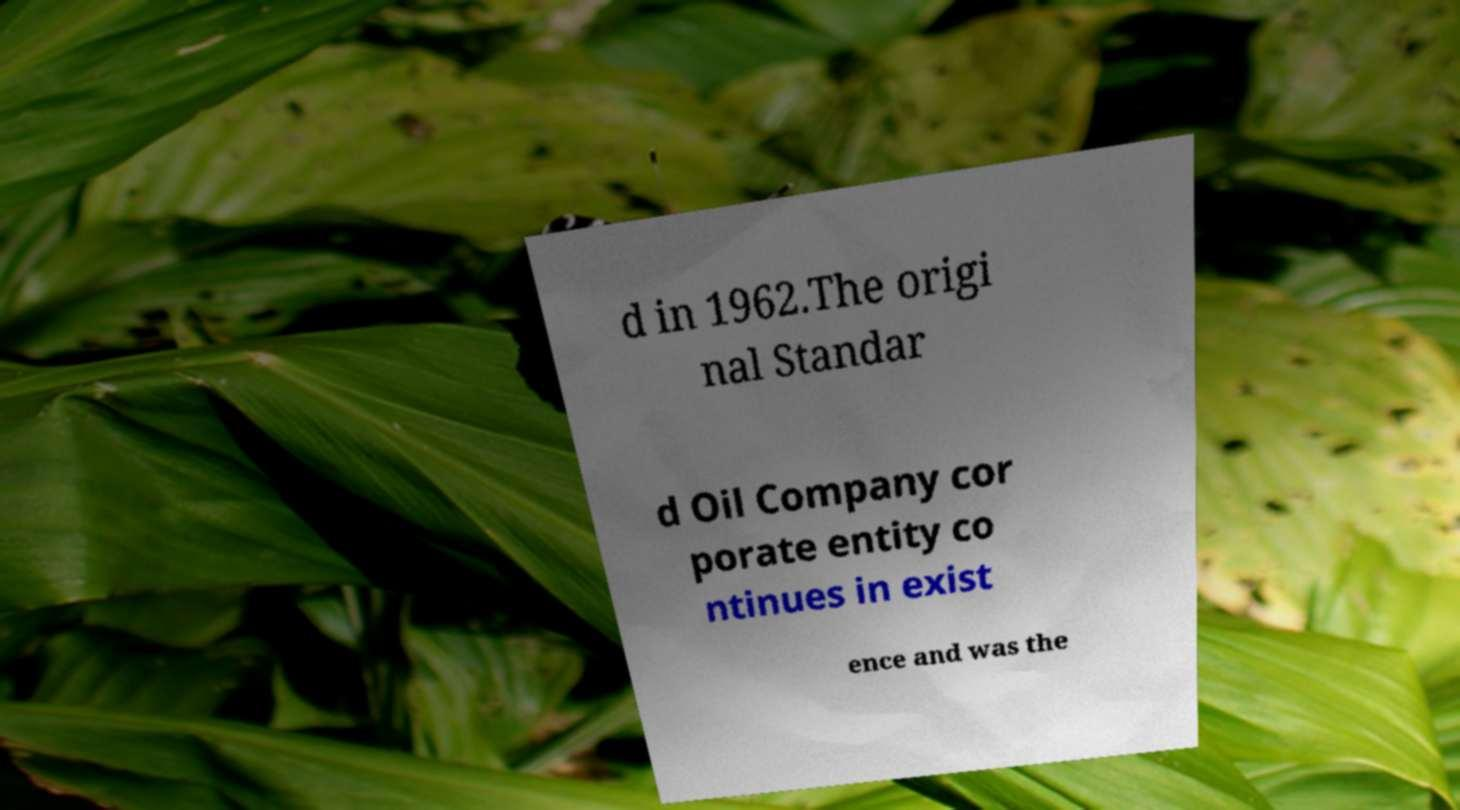I need the written content from this picture converted into text. Can you do that? d in 1962.The origi nal Standar d Oil Company cor porate entity co ntinues in exist ence and was the 